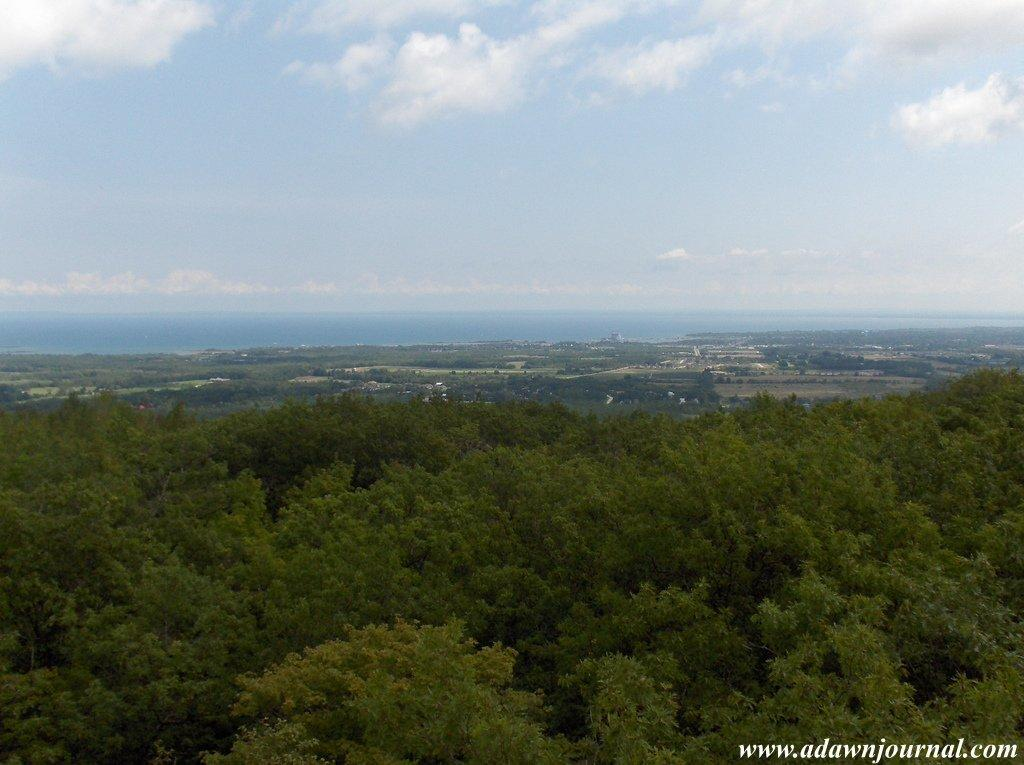What type of vegetation can be seen in the image? There is a group of trees in the image. What else is visible in the image besides the trees? The sky is visible in the image. Can you describe the sky in the image? Clouds are present in the sky. Is there any additional information about the image that might not be immediately visible? There is a watermark in the bottom right corner of the image. What type of salt can be seen on the ground in the image? There is no salt visible on the ground in the image; it only features a group of trees, the sky, clouds, and a watermark. 